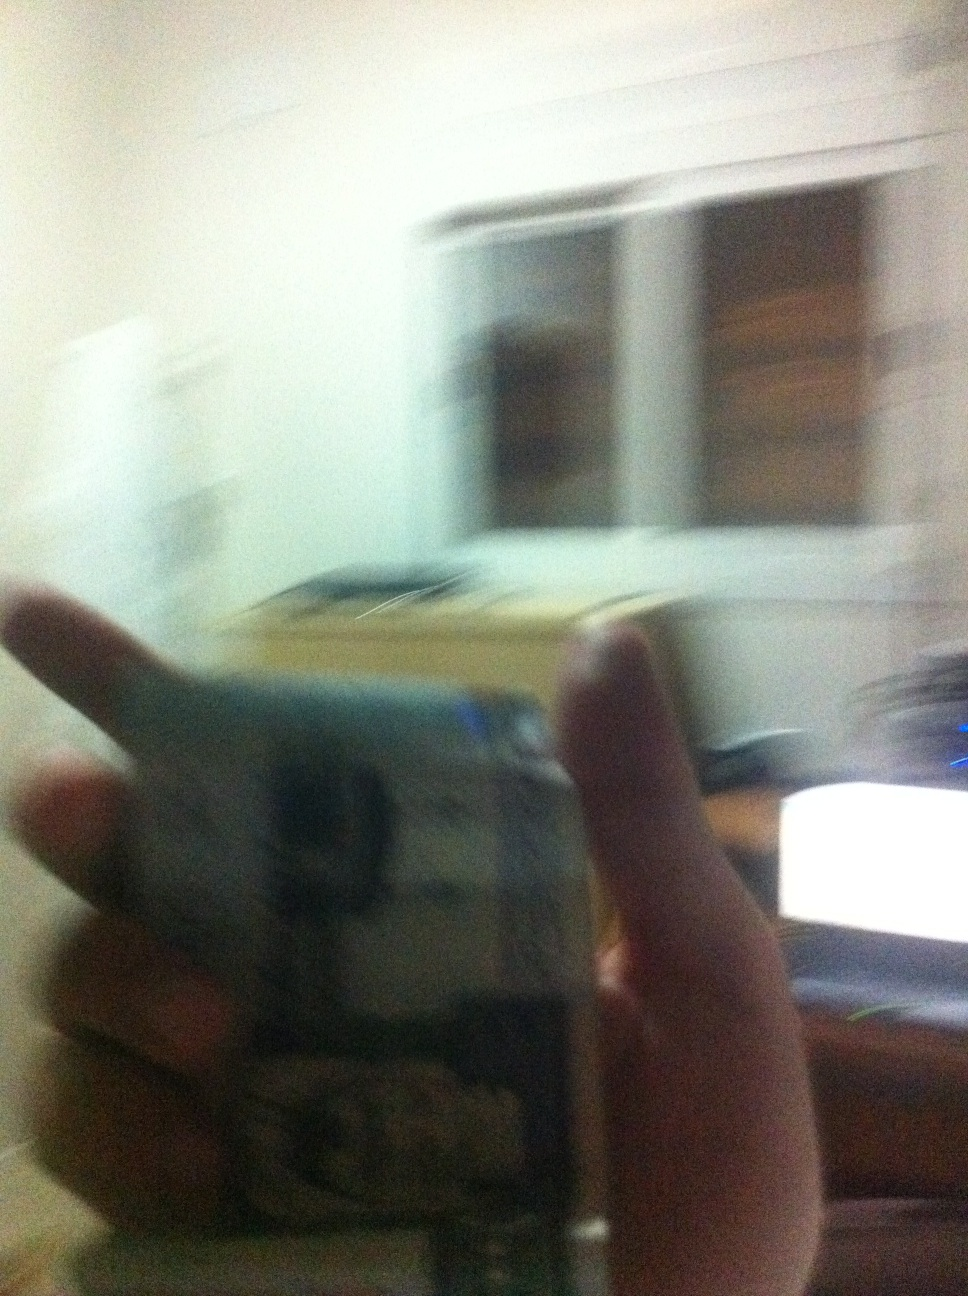Do you think the person holding the currency is about to make a significant purchase? Speculate on possible purchases. It's possible the person holding the currency is about to make a significant purchase. They could be acquiring a new piece of tech equipment for their home office, buying groceries for the upcoming week, or perhaps making a payment towards a larger bill or debt. Given the context of the room’s setting, it seems likely they are preparing for an important financial decision. 